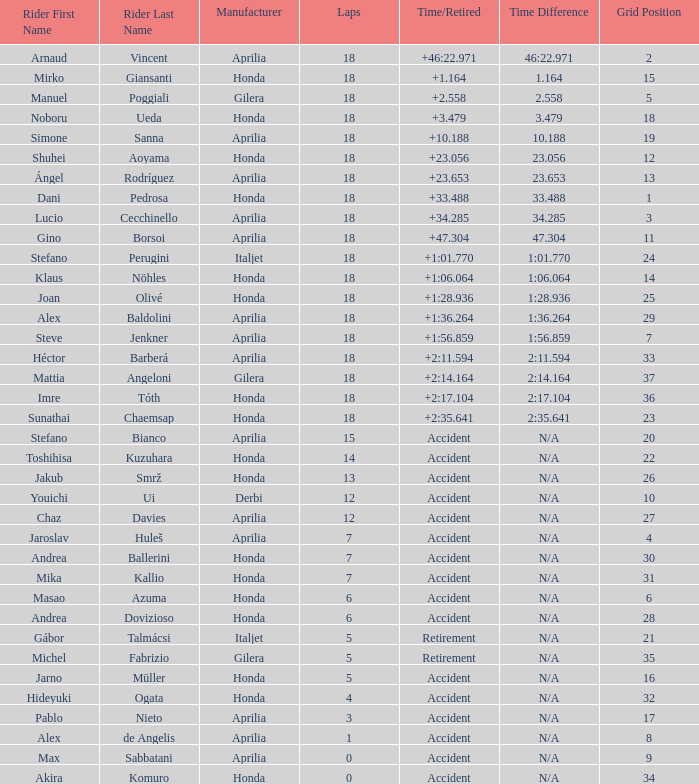What is the mean number of laps with an accident time/retired, aprilia producer and a grid of 27? 12.0. 